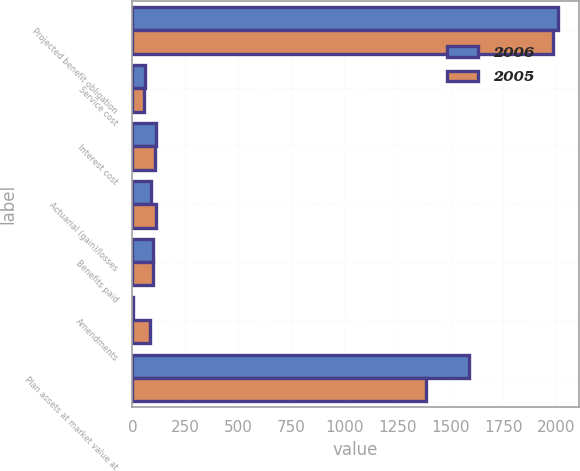Convert chart. <chart><loc_0><loc_0><loc_500><loc_500><stacked_bar_chart><ecel><fcel>Projected benefit obligation<fcel>Service cost<fcel>Interest cost<fcel>Actuarial (gain)/losses<fcel>Benefits paid<fcel>Amendments<fcel>Plan assets at market value at<nl><fcel>2006<fcel>2006<fcel>59<fcel>112<fcel>89<fcel>95<fcel>2<fcel>1588<nl><fcel>2005<fcel>1984<fcel>53<fcel>108<fcel>110<fcel>95<fcel>84<fcel>1386<nl></chart> 